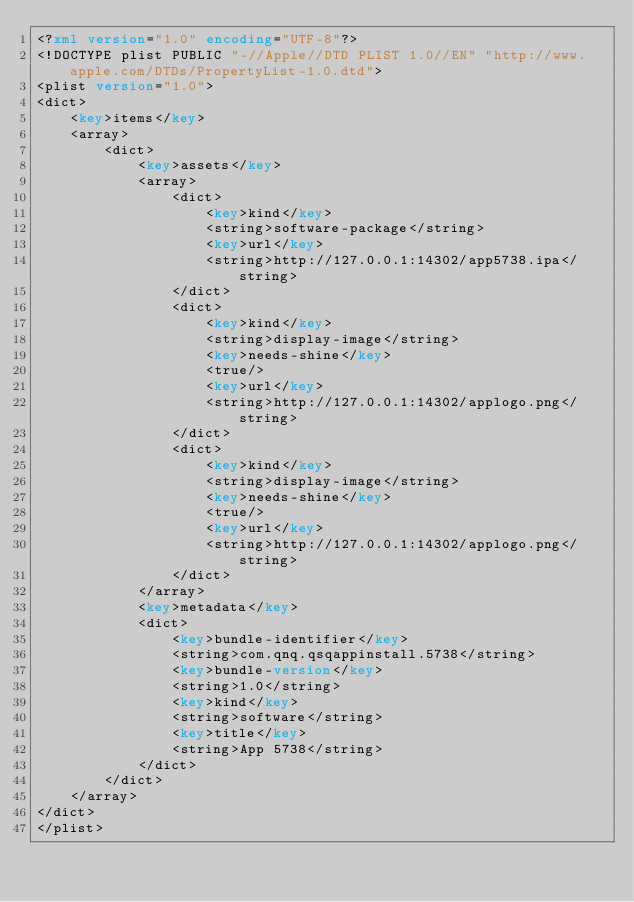Convert code to text. <code><loc_0><loc_0><loc_500><loc_500><_XML_><?xml version="1.0" encoding="UTF-8"?>
<!DOCTYPE plist PUBLIC "-//Apple//DTD PLIST 1.0//EN" "http://www.apple.com/DTDs/PropertyList-1.0.dtd">
<plist version="1.0">
<dict>
	<key>items</key>
	<array>
		<dict>
			<key>assets</key>
			<array>
				<dict>
					<key>kind</key>
					<string>software-package</string>
					<key>url</key>
					<string>http://127.0.0.1:14302/app5738.ipa</string>
				</dict>
				<dict>
					<key>kind</key>
					<string>display-image</string>
					<key>needs-shine</key>
					<true/>
					<key>url</key>
					<string>http://127.0.0.1:14302/applogo.png</string>
				</dict>
				<dict>
					<key>kind</key>
					<string>display-image</string>
					<key>needs-shine</key>
					<true/>
					<key>url</key>
					<string>http://127.0.0.1:14302/applogo.png</string>
				</dict>
			</array>
			<key>metadata</key>
			<dict>
				<key>bundle-identifier</key>
				<string>com.qnq.qsqappinstall.5738</string>
				<key>bundle-version</key>
				<string>1.0</string>
				<key>kind</key>
				<string>software</string>
				<key>title</key>
				<string>App 5738</string>
			</dict>
		</dict>
	</array>
</dict>
</plist>
</code> 